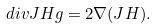Convert formula to latex. <formula><loc_0><loc_0><loc_500><loc_500>d i v J H g = 2 \nabla ( J H ) .</formula> 